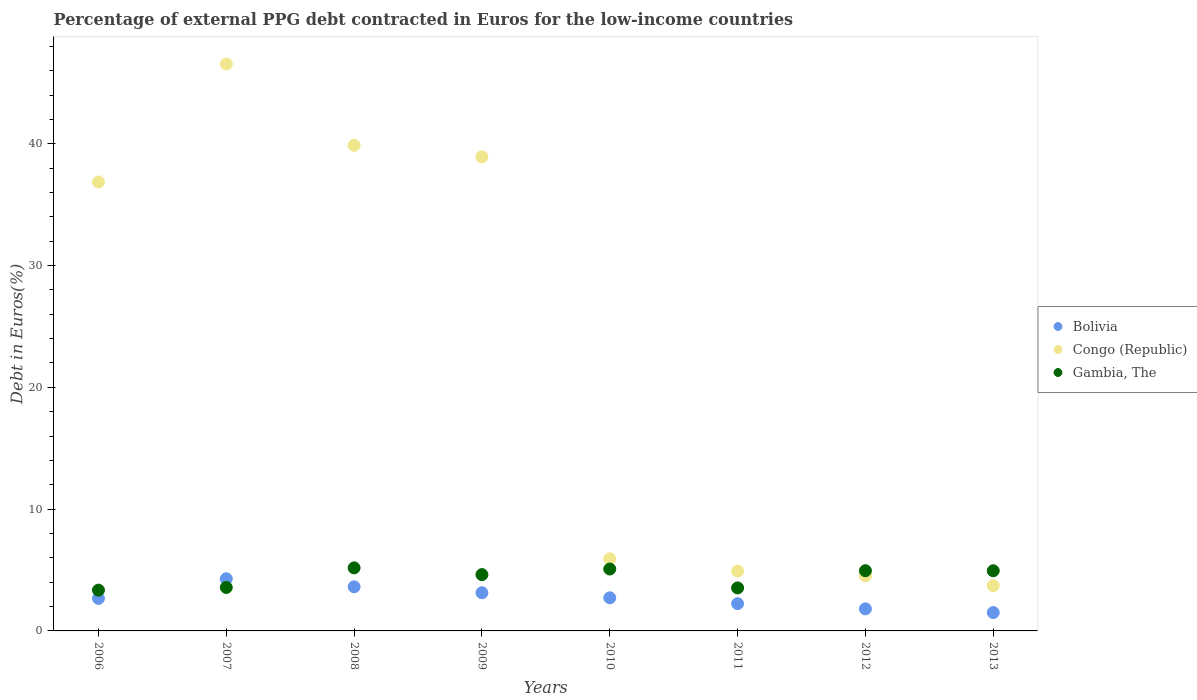What is the percentage of external PPG debt contracted in Euros in Congo (Republic) in 2009?
Your answer should be very brief. 38.93. Across all years, what is the maximum percentage of external PPG debt contracted in Euros in Bolivia?
Give a very brief answer. 4.28. Across all years, what is the minimum percentage of external PPG debt contracted in Euros in Gambia, The?
Make the answer very short. 3.35. In which year was the percentage of external PPG debt contracted in Euros in Gambia, The minimum?
Offer a very short reply. 2006. What is the total percentage of external PPG debt contracted in Euros in Congo (Republic) in the graph?
Provide a succinct answer. 181.3. What is the difference between the percentage of external PPG debt contracted in Euros in Bolivia in 2006 and that in 2009?
Provide a short and direct response. -0.46. What is the difference between the percentage of external PPG debt contracted in Euros in Congo (Republic) in 2011 and the percentage of external PPG debt contracted in Euros in Gambia, The in 2012?
Your answer should be very brief. -0.03. What is the average percentage of external PPG debt contracted in Euros in Bolivia per year?
Your response must be concise. 2.75. In the year 2007, what is the difference between the percentage of external PPG debt contracted in Euros in Congo (Republic) and percentage of external PPG debt contracted in Euros in Bolivia?
Your response must be concise. 42.27. What is the ratio of the percentage of external PPG debt contracted in Euros in Congo (Republic) in 2006 to that in 2010?
Offer a terse response. 6.22. Is the percentage of external PPG debt contracted in Euros in Bolivia in 2010 less than that in 2013?
Offer a very short reply. No. What is the difference between the highest and the second highest percentage of external PPG debt contracted in Euros in Congo (Republic)?
Provide a succinct answer. 6.67. What is the difference between the highest and the lowest percentage of external PPG debt contracted in Euros in Bolivia?
Provide a short and direct response. 2.77. In how many years, is the percentage of external PPG debt contracted in Euros in Gambia, The greater than the average percentage of external PPG debt contracted in Euros in Gambia, The taken over all years?
Offer a very short reply. 5. Is the sum of the percentage of external PPG debt contracted in Euros in Gambia, The in 2007 and 2008 greater than the maximum percentage of external PPG debt contracted in Euros in Congo (Republic) across all years?
Offer a terse response. No. Is it the case that in every year, the sum of the percentage of external PPG debt contracted in Euros in Congo (Republic) and percentage of external PPG debt contracted in Euros in Bolivia  is greater than the percentage of external PPG debt contracted in Euros in Gambia, The?
Provide a succinct answer. Yes. Is the percentage of external PPG debt contracted in Euros in Gambia, The strictly greater than the percentage of external PPG debt contracted in Euros in Bolivia over the years?
Ensure brevity in your answer.  No. Is the percentage of external PPG debt contracted in Euros in Gambia, The strictly less than the percentage of external PPG debt contracted in Euros in Bolivia over the years?
Offer a very short reply. No. How many dotlines are there?
Provide a succinct answer. 3. What is the difference between two consecutive major ticks on the Y-axis?
Keep it short and to the point. 10. Does the graph contain any zero values?
Provide a short and direct response. No. Does the graph contain grids?
Make the answer very short. No. Where does the legend appear in the graph?
Ensure brevity in your answer.  Center right. How are the legend labels stacked?
Offer a very short reply. Vertical. What is the title of the graph?
Provide a short and direct response. Percentage of external PPG debt contracted in Euros for the low-income countries. Does "El Salvador" appear as one of the legend labels in the graph?
Your answer should be compact. No. What is the label or title of the Y-axis?
Offer a terse response. Debt in Euros(%). What is the Debt in Euros(%) of Bolivia in 2006?
Keep it short and to the point. 2.67. What is the Debt in Euros(%) in Congo (Republic) in 2006?
Ensure brevity in your answer.  36.87. What is the Debt in Euros(%) in Gambia, The in 2006?
Offer a very short reply. 3.35. What is the Debt in Euros(%) of Bolivia in 2007?
Your answer should be very brief. 4.28. What is the Debt in Euros(%) in Congo (Republic) in 2007?
Provide a short and direct response. 46.55. What is the Debt in Euros(%) in Gambia, The in 2007?
Provide a short and direct response. 3.57. What is the Debt in Euros(%) of Bolivia in 2008?
Offer a terse response. 3.62. What is the Debt in Euros(%) of Congo (Republic) in 2008?
Give a very brief answer. 39.88. What is the Debt in Euros(%) of Gambia, The in 2008?
Your answer should be compact. 5.18. What is the Debt in Euros(%) of Bolivia in 2009?
Keep it short and to the point. 3.13. What is the Debt in Euros(%) of Congo (Republic) in 2009?
Your answer should be very brief. 38.93. What is the Debt in Euros(%) of Gambia, The in 2009?
Provide a short and direct response. 4.62. What is the Debt in Euros(%) of Bolivia in 2010?
Your response must be concise. 2.72. What is the Debt in Euros(%) in Congo (Republic) in 2010?
Provide a short and direct response. 5.93. What is the Debt in Euros(%) in Gambia, The in 2010?
Make the answer very short. 5.08. What is the Debt in Euros(%) of Bolivia in 2011?
Offer a terse response. 2.24. What is the Debt in Euros(%) of Congo (Republic) in 2011?
Ensure brevity in your answer.  4.91. What is the Debt in Euros(%) of Gambia, The in 2011?
Offer a terse response. 3.53. What is the Debt in Euros(%) in Bolivia in 2012?
Your answer should be very brief. 1.81. What is the Debt in Euros(%) in Congo (Republic) in 2012?
Provide a succinct answer. 4.52. What is the Debt in Euros(%) of Gambia, The in 2012?
Your response must be concise. 4.94. What is the Debt in Euros(%) of Bolivia in 2013?
Make the answer very short. 1.51. What is the Debt in Euros(%) in Congo (Republic) in 2013?
Offer a very short reply. 3.72. What is the Debt in Euros(%) in Gambia, The in 2013?
Provide a succinct answer. 4.94. Across all years, what is the maximum Debt in Euros(%) in Bolivia?
Your response must be concise. 4.28. Across all years, what is the maximum Debt in Euros(%) in Congo (Republic)?
Provide a short and direct response. 46.55. Across all years, what is the maximum Debt in Euros(%) in Gambia, The?
Provide a short and direct response. 5.18. Across all years, what is the minimum Debt in Euros(%) of Bolivia?
Provide a succinct answer. 1.51. Across all years, what is the minimum Debt in Euros(%) in Congo (Republic)?
Make the answer very short. 3.72. Across all years, what is the minimum Debt in Euros(%) in Gambia, The?
Your answer should be compact. 3.35. What is the total Debt in Euros(%) of Bolivia in the graph?
Your answer should be very brief. 21.98. What is the total Debt in Euros(%) in Congo (Republic) in the graph?
Provide a succinct answer. 181.3. What is the total Debt in Euros(%) of Gambia, The in the graph?
Your response must be concise. 35.22. What is the difference between the Debt in Euros(%) in Bolivia in 2006 and that in 2007?
Your answer should be very brief. -1.61. What is the difference between the Debt in Euros(%) in Congo (Republic) in 2006 and that in 2007?
Offer a terse response. -9.69. What is the difference between the Debt in Euros(%) in Gambia, The in 2006 and that in 2007?
Provide a short and direct response. -0.22. What is the difference between the Debt in Euros(%) in Bolivia in 2006 and that in 2008?
Offer a terse response. -0.95. What is the difference between the Debt in Euros(%) of Congo (Republic) in 2006 and that in 2008?
Offer a very short reply. -3.01. What is the difference between the Debt in Euros(%) in Gambia, The in 2006 and that in 2008?
Your response must be concise. -1.83. What is the difference between the Debt in Euros(%) in Bolivia in 2006 and that in 2009?
Your answer should be very brief. -0.46. What is the difference between the Debt in Euros(%) in Congo (Republic) in 2006 and that in 2009?
Make the answer very short. -2.06. What is the difference between the Debt in Euros(%) in Gambia, The in 2006 and that in 2009?
Provide a short and direct response. -1.27. What is the difference between the Debt in Euros(%) of Bolivia in 2006 and that in 2010?
Make the answer very short. -0.05. What is the difference between the Debt in Euros(%) in Congo (Republic) in 2006 and that in 2010?
Give a very brief answer. 30.94. What is the difference between the Debt in Euros(%) in Gambia, The in 2006 and that in 2010?
Offer a terse response. -1.73. What is the difference between the Debt in Euros(%) of Bolivia in 2006 and that in 2011?
Ensure brevity in your answer.  0.43. What is the difference between the Debt in Euros(%) of Congo (Republic) in 2006 and that in 2011?
Ensure brevity in your answer.  31.95. What is the difference between the Debt in Euros(%) in Gambia, The in 2006 and that in 2011?
Your answer should be compact. -0.18. What is the difference between the Debt in Euros(%) in Bolivia in 2006 and that in 2012?
Give a very brief answer. 0.86. What is the difference between the Debt in Euros(%) of Congo (Republic) in 2006 and that in 2012?
Your answer should be very brief. 32.35. What is the difference between the Debt in Euros(%) in Gambia, The in 2006 and that in 2012?
Offer a very short reply. -1.6. What is the difference between the Debt in Euros(%) in Bolivia in 2006 and that in 2013?
Give a very brief answer. 1.16. What is the difference between the Debt in Euros(%) in Congo (Republic) in 2006 and that in 2013?
Your answer should be compact. 33.15. What is the difference between the Debt in Euros(%) of Gambia, The in 2006 and that in 2013?
Your answer should be compact. -1.59. What is the difference between the Debt in Euros(%) in Bolivia in 2007 and that in 2008?
Make the answer very short. 0.66. What is the difference between the Debt in Euros(%) in Congo (Republic) in 2007 and that in 2008?
Give a very brief answer. 6.67. What is the difference between the Debt in Euros(%) in Gambia, The in 2007 and that in 2008?
Your response must be concise. -1.61. What is the difference between the Debt in Euros(%) of Bolivia in 2007 and that in 2009?
Offer a very short reply. 1.15. What is the difference between the Debt in Euros(%) of Congo (Republic) in 2007 and that in 2009?
Your answer should be compact. 7.62. What is the difference between the Debt in Euros(%) in Gambia, The in 2007 and that in 2009?
Keep it short and to the point. -1.05. What is the difference between the Debt in Euros(%) in Bolivia in 2007 and that in 2010?
Your answer should be compact. 1.56. What is the difference between the Debt in Euros(%) of Congo (Republic) in 2007 and that in 2010?
Your answer should be compact. 40.62. What is the difference between the Debt in Euros(%) in Gambia, The in 2007 and that in 2010?
Provide a succinct answer. -1.51. What is the difference between the Debt in Euros(%) of Bolivia in 2007 and that in 2011?
Give a very brief answer. 2.04. What is the difference between the Debt in Euros(%) of Congo (Republic) in 2007 and that in 2011?
Provide a short and direct response. 41.64. What is the difference between the Debt in Euros(%) of Gambia, The in 2007 and that in 2011?
Keep it short and to the point. 0.04. What is the difference between the Debt in Euros(%) of Bolivia in 2007 and that in 2012?
Keep it short and to the point. 2.47. What is the difference between the Debt in Euros(%) in Congo (Republic) in 2007 and that in 2012?
Give a very brief answer. 42.04. What is the difference between the Debt in Euros(%) of Gambia, The in 2007 and that in 2012?
Your answer should be very brief. -1.38. What is the difference between the Debt in Euros(%) in Bolivia in 2007 and that in 2013?
Offer a very short reply. 2.77. What is the difference between the Debt in Euros(%) of Congo (Republic) in 2007 and that in 2013?
Make the answer very short. 42.83. What is the difference between the Debt in Euros(%) of Gambia, The in 2007 and that in 2013?
Your answer should be compact. -1.37. What is the difference between the Debt in Euros(%) in Bolivia in 2008 and that in 2009?
Your answer should be very brief. 0.49. What is the difference between the Debt in Euros(%) of Congo (Republic) in 2008 and that in 2009?
Keep it short and to the point. 0.95. What is the difference between the Debt in Euros(%) of Gambia, The in 2008 and that in 2009?
Your answer should be compact. 0.55. What is the difference between the Debt in Euros(%) of Bolivia in 2008 and that in 2010?
Your answer should be very brief. 0.9. What is the difference between the Debt in Euros(%) of Congo (Republic) in 2008 and that in 2010?
Make the answer very short. 33.95. What is the difference between the Debt in Euros(%) of Gambia, The in 2008 and that in 2010?
Provide a succinct answer. 0.09. What is the difference between the Debt in Euros(%) of Bolivia in 2008 and that in 2011?
Provide a succinct answer. 1.38. What is the difference between the Debt in Euros(%) of Congo (Republic) in 2008 and that in 2011?
Ensure brevity in your answer.  34.97. What is the difference between the Debt in Euros(%) of Gambia, The in 2008 and that in 2011?
Keep it short and to the point. 1.64. What is the difference between the Debt in Euros(%) in Bolivia in 2008 and that in 2012?
Offer a terse response. 1.81. What is the difference between the Debt in Euros(%) in Congo (Republic) in 2008 and that in 2012?
Your answer should be very brief. 35.36. What is the difference between the Debt in Euros(%) in Gambia, The in 2008 and that in 2012?
Give a very brief answer. 0.23. What is the difference between the Debt in Euros(%) of Bolivia in 2008 and that in 2013?
Keep it short and to the point. 2.11. What is the difference between the Debt in Euros(%) of Congo (Republic) in 2008 and that in 2013?
Offer a terse response. 36.16. What is the difference between the Debt in Euros(%) of Gambia, The in 2008 and that in 2013?
Make the answer very short. 0.24. What is the difference between the Debt in Euros(%) of Bolivia in 2009 and that in 2010?
Offer a very short reply. 0.41. What is the difference between the Debt in Euros(%) of Congo (Republic) in 2009 and that in 2010?
Provide a succinct answer. 33. What is the difference between the Debt in Euros(%) in Gambia, The in 2009 and that in 2010?
Give a very brief answer. -0.46. What is the difference between the Debt in Euros(%) in Bolivia in 2009 and that in 2011?
Ensure brevity in your answer.  0.9. What is the difference between the Debt in Euros(%) of Congo (Republic) in 2009 and that in 2011?
Provide a succinct answer. 34.01. What is the difference between the Debt in Euros(%) in Gambia, The in 2009 and that in 2011?
Make the answer very short. 1.09. What is the difference between the Debt in Euros(%) of Bolivia in 2009 and that in 2012?
Ensure brevity in your answer.  1.32. What is the difference between the Debt in Euros(%) of Congo (Republic) in 2009 and that in 2012?
Your response must be concise. 34.41. What is the difference between the Debt in Euros(%) in Gambia, The in 2009 and that in 2012?
Ensure brevity in your answer.  -0.32. What is the difference between the Debt in Euros(%) of Bolivia in 2009 and that in 2013?
Offer a terse response. 1.63. What is the difference between the Debt in Euros(%) in Congo (Republic) in 2009 and that in 2013?
Make the answer very short. 35.21. What is the difference between the Debt in Euros(%) in Gambia, The in 2009 and that in 2013?
Give a very brief answer. -0.32. What is the difference between the Debt in Euros(%) of Bolivia in 2010 and that in 2011?
Keep it short and to the point. 0.48. What is the difference between the Debt in Euros(%) of Congo (Republic) in 2010 and that in 2011?
Give a very brief answer. 1.01. What is the difference between the Debt in Euros(%) of Gambia, The in 2010 and that in 2011?
Offer a very short reply. 1.55. What is the difference between the Debt in Euros(%) in Bolivia in 2010 and that in 2012?
Your answer should be very brief. 0.91. What is the difference between the Debt in Euros(%) of Congo (Republic) in 2010 and that in 2012?
Offer a very short reply. 1.41. What is the difference between the Debt in Euros(%) of Gambia, The in 2010 and that in 2012?
Provide a succinct answer. 0.14. What is the difference between the Debt in Euros(%) of Bolivia in 2010 and that in 2013?
Give a very brief answer. 1.21. What is the difference between the Debt in Euros(%) in Congo (Republic) in 2010 and that in 2013?
Make the answer very short. 2.21. What is the difference between the Debt in Euros(%) in Gambia, The in 2010 and that in 2013?
Your answer should be compact. 0.14. What is the difference between the Debt in Euros(%) of Bolivia in 2011 and that in 2012?
Ensure brevity in your answer.  0.43. What is the difference between the Debt in Euros(%) of Congo (Republic) in 2011 and that in 2012?
Keep it short and to the point. 0.4. What is the difference between the Debt in Euros(%) of Gambia, The in 2011 and that in 2012?
Provide a short and direct response. -1.41. What is the difference between the Debt in Euros(%) in Bolivia in 2011 and that in 2013?
Provide a short and direct response. 0.73. What is the difference between the Debt in Euros(%) of Congo (Republic) in 2011 and that in 2013?
Ensure brevity in your answer.  1.19. What is the difference between the Debt in Euros(%) in Gambia, The in 2011 and that in 2013?
Give a very brief answer. -1.41. What is the difference between the Debt in Euros(%) of Bolivia in 2012 and that in 2013?
Provide a succinct answer. 0.3. What is the difference between the Debt in Euros(%) of Congo (Republic) in 2012 and that in 2013?
Make the answer very short. 0.8. What is the difference between the Debt in Euros(%) in Gambia, The in 2012 and that in 2013?
Make the answer very short. 0.01. What is the difference between the Debt in Euros(%) in Bolivia in 2006 and the Debt in Euros(%) in Congo (Republic) in 2007?
Your response must be concise. -43.88. What is the difference between the Debt in Euros(%) in Bolivia in 2006 and the Debt in Euros(%) in Gambia, The in 2007?
Provide a succinct answer. -0.9. What is the difference between the Debt in Euros(%) of Congo (Republic) in 2006 and the Debt in Euros(%) of Gambia, The in 2007?
Your answer should be compact. 33.3. What is the difference between the Debt in Euros(%) in Bolivia in 2006 and the Debt in Euros(%) in Congo (Republic) in 2008?
Provide a short and direct response. -37.21. What is the difference between the Debt in Euros(%) of Bolivia in 2006 and the Debt in Euros(%) of Gambia, The in 2008?
Your response must be concise. -2.51. What is the difference between the Debt in Euros(%) of Congo (Republic) in 2006 and the Debt in Euros(%) of Gambia, The in 2008?
Your answer should be very brief. 31.69. What is the difference between the Debt in Euros(%) in Bolivia in 2006 and the Debt in Euros(%) in Congo (Republic) in 2009?
Keep it short and to the point. -36.26. What is the difference between the Debt in Euros(%) of Bolivia in 2006 and the Debt in Euros(%) of Gambia, The in 2009?
Your answer should be very brief. -1.95. What is the difference between the Debt in Euros(%) of Congo (Republic) in 2006 and the Debt in Euros(%) of Gambia, The in 2009?
Ensure brevity in your answer.  32.24. What is the difference between the Debt in Euros(%) in Bolivia in 2006 and the Debt in Euros(%) in Congo (Republic) in 2010?
Provide a succinct answer. -3.26. What is the difference between the Debt in Euros(%) of Bolivia in 2006 and the Debt in Euros(%) of Gambia, The in 2010?
Offer a very short reply. -2.41. What is the difference between the Debt in Euros(%) of Congo (Republic) in 2006 and the Debt in Euros(%) of Gambia, The in 2010?
Ensure brevity in your answer.  31.78. What is the difference between the Debt in Euros(%) of Bolivia in 2006 and the Debt in Euros(%) of Congo (Republic) in 2011?
Offer a terse response. -2.24. What is the difference between the Debt in Euros(%) of Bolivia in 2006 and the Debt in Euros(%) of Gambia, The in 2011?
Offer a very short reply. -0.86. What is the difference between the Debt in Euros(%) of Congo (Republic) in 2006 and the Debt in Euros(%) of Gambia, The in 2011?
Offer a terse response. 33.33. What is the difference between the Debt in Euros(%) in Bolivia in 2006 and the Debt in Euros(%) in Congo (Republic) in 2012?
Your response must be concise. -1.85. What is the difference between the Debt in Euros(%) of Bolivia in 2006 and the Debt in Euros(%) of Gambia, The in 2012?
Your answer should be very brief. -2.27. What is the difference between the Debt in Euros(%) of Congo (Republic) in 2006 and the Debt in Euros(%) of Gambia, The in 2012?
Offer a terse response. 31.92. What is the difference between the Debt in Euros(%) in Bolivia in 2006 and the Debt in Euros(%) in Congo (Republic) in 2013?
Make the answer very short. -1.05. What is the difference between the Debt in Euros(%) of Bolivia in 2006 and the Debt in Euros(%) of Gambia, The in 2013?
Make the answer very short. -2.27. What is the difference between the Debt in Euros(%) in Congo (Republic) in 2006 and the Debt in Euros(%) in Gambia, The in 2013?
Keep it short and to the point. 31.93. What is the difference between the Debt in Euros(%) of Bolivia in 2007 and the Debt in Euros(%) of Congo (Republic) in 2008?
Keep it short and to the point. -35.6. What is the difference between the Debt in Euros(%) in Bolivia in 2007 and the Debt in Euros(%) in Gambia, The in 2008?
Offer a very short reply. -0.9. What is the difference between the Debt in Euros(%) of Congo (Republic) in 2007 and the Debt in Euros(%) of Gambia, The in 2008?
Give a very brief answer. 41.38. What is the difference between the Debt in Euros(%) in Bolivia in 2007 and the Debt in Euros(%) in Congo (Republic) in 2009?
Provide a succinct answer. -34.65. What is the difference between the Debt in Euros(%) in Bolivia in 2007 and the Debt in Euros(%) in Gambia, The in 2009?
Offer a very short reply. -0.34. What is the difference between the Debt in Euros(%) of Congo (Republic) in 2007 and the Debt in Euros(%) of Gambia, The in 2009?
Give a very brief answer. 41.93. What is the difference between the Debt in Euros(%) in Bolivia in 2007 and the Debt in Euros(%) in Congo (Republic) in 2010?
Your answer should be very brief. -1.65. What is the difference between the Debt in Euros(%) of Bolivia in 2007 and the Debt in Euros(%) of Gambia, The in 2010?
Offer a terse response. -0.8. What is the difference between the Debt in Euros(%) in Congo (Republic) in 2007 and the Debt in Euros(%) in Gambia, The in 2010?
Ensure brevity in your answer.  41.47. What is the difference between the Debt in Euros(%) in Bolivia in 2007 and the Debt in Euros(%) in Congo (Republic) in 2011?
Offer a terse response. -0.63. What is the difference between the Debt in Euros(%) of Bolivia in 2007 and the Debt in Euros(%) of Gambia, The in 2011?
Provide a succinct answer. 0.75. What is the difference between the Debt in Euros(%) in Congo (Republic) in 2007 and the Debt in Euros(%) in Gambia, The in 2011?
Ensure brevity in your answer.  43.02. What is the difference between the Debt in Euros(%) of Bolivia in 2007 and the Debt in Euros(%) of Congo (Republic) in 2012?
Provide a succinct answer. -0.24. What is the difference between the Debt in Euros(%) in Bolivia in 2007 and the Debt in Euros(%) in Gambia, The in 2012?
Make the answer very short. -0.66. What is the difference between the Debt in Euros(%) of Congo (Republic) in 2007 and the Debt in Euros(%) of Gambia, The in 2012?
Provide a short and direct response. 41.61. What is the difference between the Debt in Euros(%) in Bolivia in 2007 and the Debt in Euros(%) in Congo (Republic) in 2013?
Make the answer very short. 0.56. What is the difference between the Debt in Euros(%) of Bolivia in 2007 and the Debt in Euros(%) of Gambia, The in 2013?
Your answer should be very brief. -0.66. What is the difference between the Debt in Euros(%) of Congo (Republic) in 2007 and the Debt in Euros(%) of Gambia, The in 2013?
Offer a very short reply. 41.61. What is the difference between the Debt in Euros(%) of Bolivia in 2008 and the Debt in Euros(%) of Congo (Republic) in 2009?
Make the answer very short. -35.3. What is the difference between the Debt in Euros(%) of Bolivia in 2008 and the Debt in Euros(%) of Gambia, The in 2009?
Your answer should be compact. -1. What is the difference between the Debt in Euros(%) of Congo (Republic) in 2008 and the Debt in Euros(%) of Gambia, The in 2009?
Your answer should be compact. 35.26. What is the difference between the Debt in Euros(%) in Bolivia in 2008 and the Debt in Euros(%) in Congo (Republic) in 2010?
Provide a short and direct response. -2.31. What is the difference between the Debt in Euros(%) in Bolivia in 2008 and the Debt in Euros(%) in Gambia, The in 2010?
Make the answer very short. -1.46. What is the difference between the Debt in Euros(%) in Congo (Republic) in 2008 and the Debt in Euros(%) in Gambia, The in 2010?
Keep it short and to the point. 34.8. What is the difference between the Debt in Euros(%) of Bolivia in 2008 and the Debt in Euros(%) of Congo (Republic) in 2011?
Provide a succinct answer. -1.29. What is the difference between the Debt in Euros(%) in Bolivia in 2008 and the Debt in Euros(%) in Gambia, The in 2011?
Your response must be concise. 0.09. What is the difference between the Debt in Euros(%) of Congo (Republic) in 2008 and the Debt in Euros(%) of Gambia, The in 2011?
Make the answer very short. 36.35. What is the difference between the Debt in Euros(%) in Bolivia in 2008 and the Debt in Euros(%) in Congo (Republic) in 2012?
Your answer should be very brief. -0.89. What is the difference between the Debt in Euros(%) in Bolivia in 2008 and the Debt in Euros(%) in Gambia, The in 2012?
Make the answer very short. -1.32. What is the difference between the Debt in Euros(%) in Congo (Republic) in 2008 and the Debt in Euros(%) in Gambia, The in 2012?
Keep it short and to the point. 34.93. What is the difference between the Debt in Euros(%) of Bolivia in 2008 and the Debt in Euros(%) of Congo (Republic) in 2013?
Provide a succinct answer. -0.1. What is the difference between the Debt in Euros(%) of Bolivia in 2008 and the Debt in Euros(%) of Gambia, The in 2013?
Keep it short and to the point. -1.32. What is the difference between the Debt in Euros(%) in Congo (Republic) in 2008 and the Debt in Euros(%) in Gambia, The in 2013?
Offer a very short reply. 34.94. What is the difference between the Debt in Euros(%) in Bolivia in 2009 and the Debt in Euros(%) in Congo (Republic) in 2010?
Your answer should be very brief. -2.79. What is the difference between the Debt in Euros(%) in Bolivia in 2009 and the Debt in Euros(%) in Gambia, The in 2010?
Make the answer very short. -1.95. What is the difference between the Debt in Euros(%) in Congo (Republic) in 2009 and the Debt in Euros(%) in Gambia, The in 2010?
Keep it short and to the point. 33.84. What is the difference between the Debt in Euros(%) in Bolivia in 2009 and the Debt in Euros(%) in Congo (Republic) in 2011?
Your answer should be very brief. -1.78. What is the difference between the Debt in Euros(%) in Bolivia in 2009 and the Debt in Euros(%) in Gambia, The in 2011?
Your answer should be compact. -0.4. What is the difference between the Debt in Euros(%) in Congo (Republic) in 2009 and the Debt in Euros(%) in Gambia, The in 2011?
Ensure brevity in your answer.  35.39. What is the difference between the Debt in Euros(%) of Bolivia in 2009 and the Debt in Euros(%) of Congo (Republic) in 2012?
Your answer should be compact. -1.38. What is the difference between the Debt in Euros(%) of Bolivia in 2009 and the Debt in Euros(%) of Gambia, The in 2012?
Your answer should be compact. -1.81. What is the difference between the Debt in Euros(%) of Congo (Republic) in 2009 and the Debt in Euros(%) of Gambia, The in 2012?
Provide a short and direct response. 33.98. What is the difference between the Debt in Euros(%) of Bolivia in 2009 and the Debt in Euros(%) of Congo (Republic) in 2013?
Offer a terse response. -0.59. What is the difference between the Debt in Euros(%) of Bolivia in 2009 and the Debt in Euros(%) of Gambia, The in 2013?
Your response must be concise. -1.81. What is the difference between the Debt in Euros(%) in Congo (Republic) in 2009 and the Debt in Euros(%) in Gambia, The in 2013?
Your answer should be compact. 33.99. What is the difference between the Debt in Euros(%) in Bolivia in 2010 and the Debt in Euros(%) in Congo (Republic) in 2011?
Provide a succinct answer. -2.19. What is the difference between the Debt in Euros(%) in Bolivia in 2010 and the Debt in Euros(%) in Gambia, The in 2011?
Offer a very short reply. -0.81. What is the difference between the Debt in Euros(%) in Congo (Republic) in 2010 and the Debt in Euros(%) in Gambia, The in 2011?
Offer a very short reply. 2.4. What is the difference between the Debt in Euros(%) of Bolivia in 2010 and the Debt in Euros(%) of Congo (Republic) in 2012?
Provide a short and direct response. -1.8. What is the difference between the Debt in Euros(%) of Bolivia in 2010 and the Debt in Euros(%) of Gambia, The in 2012?
Make the answer very short. -2.23. What is the difference between the Debt in Euros(%) in Congo (Republic) in 2010 and the Debt in Euros(%) in Gambia, The in 2012?
Your response must be concise. 0.98. What is the difference between the Debt in Euros(%) in Bolivia in 2010 and the Debt in Euros(%) in Congo (Republic) in 2013?
Provide a short and direct response. -1. What is the difference between the Debt in Euros(%) in Bolivia in 2010 and the Debt in Euros(%) in Gambia, The in 2013?
Your answer should be very brief. -2.22. What is the difference between the Debt in Euros(%) in Congo (Republic) in 2010 and the Debt in Euros(%) in Gambia, The in 2013?
Make the answer very short. 0.99. What is the difference between the Debt in Euros(%) of Bolivia in 2011 and the Debt in Euros(%) of Congo (Republic) in 2012?
Provide a short and direct response. -2.28. What is the difference between the Debt in Euros(%) in Bolivia in 2011 and the Debt in Euros(%) in Gambia, The in 2012?
Your response must be concise. -2.71. What is the difference between the Debt in Euros(%) in Congo (Republic) in 2011 and the Debt in Euros(%) in Gambia, The in 2012?
Offer a terse response. -0.03. What is the difference between the Debt in Euros(%) of Bolivia in 2011 and the Debt in Euros(%) of Congo (Republic) in 2013?
Provide a succinct answer. -1.48. What is the difference between the Debt in Euros(%) in Bolivia in 2011 and the Debt in Euros(%) in Gambia, The in 2013?
Your answer should be compact. -2.7. What is the difference between the Debt in Euros(%) in Congo (Republic) in 2011 and the Debt in Euros(%) in Gambia, The in 2013?
Your answer should be very brief. -0.03. What is the difference between the Debt in Euros(%) in Bolivia in 2012 and the Debt in Euros(%) in Congo (Republic) in 2013?
Make the answer very short. -1.91. What is the difference between the Debt in Euros(%) of Bolivia in 2012 and the Debt in Euros(%) of Gambia, The in 2013?
Your answer should be very brief. -3.13. What is the difference between the Debt in Euros(%) in Congo (Republic) in 2012 and the Debt in Euros(%) in Gambia, The in 2013?
Give a very brief answer. -0.42. What is the average Debt in Euros(%) in Bolivia per year?
Offer a terse response. 2.75. What is the average Debt in Euros(%) of Congo (Republic) per year?
Offer a terse response. 22.66. What is the average Debt in Euros(%) of Gambia, The per year?
Your answer should be compact. 4.4. In the year 2006, what is the difference between the Debt in Euros(%) in Bolivia and Debt in Euros(%) in Congo (Republic)?
Your response must be concise. -34.19. In the year 2006, what is the difference between the Debt in Euros(%) of Bolivia and Debt in Euros(%) of Gambia, The?
Make the answer very short. -0.68. In the year 2006, what is the difference between the Debt in Euros(%) of Congo (Republic) and Debt in Euros(%) of Gambia, The?
Your answer should be compact. 33.52. In the year 2007, what is the difference between the Debt in Euros(%) of Bolivia and Debt in Euros(%) of Congo (Republic)?
Make the answer very short. -42.27. In the year 2007, what is the difference between the Debt in Euros(%) of Bolivia and Debt in Euros(%) of Gambia, The?
Your answer should be compact. 0.71. In the year 2007, what is the difference between the Debt in Euros(%) of Congo (Republic) and Debt in Euros(%) of Gambia, The?
Your answer should be compact. 42.98. In the year 2008, what is the difference between the Debt in Euros(%) in Bolivia and Debt in Euros(%) in Congo (Republic)?
Offer a very short reply. -36.26. In the year 2008, what is the difference between the Debt in Euros(%) in Bolivia and Debt in Euros(%) in Gambia, The?
Make the answer very short. -1.55. In the year 2008, what is the difference between the Debt in Euros(%) in Congo (Republic) and Debt in Euros(%) in Gambia, The?
Make the answer very short. 34.7. In the year 2009, what is the difference between the Debt in Euros(%) of Bolivia and Debt in Euros(%) of Congo (Republic)?
Give a very brief answer. -35.79. In the year 2009, what is the difference between the Debt in Euros(%) in Bolivia and Debt in Euros(%) in Gambia, The?
Keep it short and to the point. -1.49. In the year 2009, what is the difference between the Debt in Euros(%) in Congo (Republic) and Debt in Euros(%) in Gambia, The?
Offer a very short reply. 34.3. In the year 2010, what is the difference between the Debt in Euros(%) in Bolivia and Debt in Euros(%) in Congo (Republic)?
Make the answer very short. -3.21. In the year 2010, what is the difference between the Debt in Euros(%) of Bolivia and Debt in Euros(%) of Gambia, The?
Provide a succinct answer. -2.36. In the year 2010, what is the difference between the Debt in Euros(%) in Congo (Republic) and Debt in Euros(%) in Gambia, The?
Offer a very short reply. 0.84. In the year 2011, what is the difference between the Debt in Euros(%) of Bolivia and Debt in Euros(%) of Congo (Republic)?
Make the answer very short. -2.67. In the year 2011, what is the difference between the Debt in Euros(%) in Bolivia and Debt in Euros(%) in Gambia, The?
Give a very brief answer. -1.29. In the year 2011, what is the difference between the Debt in Euros(%) in Congo (Republic) and Debt in Euros(%) in Gambia, The?
Ensure brevity in your answer.  1.38. In the year 2012, what is the difference between the Debt in Euros(%) of Bolivia and Debt in Euros(%) of Congo (Republic)?
Ensure brevity in your answer.  -2.71. In the year 2012, what is the difference between the Debt in Euros(%) of Bolivia and Debt in Euros(%) of Gambia, The?
Provide a succinct answer. -3.13. In the year 2012, what is the difference between the Debt in Euros(%) in Congo (Republic) and Debt in Euros(%) in Gambia, The?
Give a very brief answer. -0.43. In the year 2013, what is the difference between the Debt in Euros(%) of Bolivia and Debt in Euros(%) of Congo (Republic)?
Ensure brevity in your answer.  -2.21. In the year 2013, what is the difference between the Debt in Euros(%) of Bolivia and Debt in Euros(%) of Gambia, The?
Your answer should be compact. -3.43. In the year 2013, what is the difference between the Debt in Euros(%) of Congo (Republic) and Debt in Euros(%) of Gambia, The?
Provide a short and direct response. -1.22. What is the ratio of the Debt in Euros(%) in Bolivia in 2006 to that in 2007?
Provide a succinct answer. 0.62. What is the ratio of the Debt in Euros(%) in Congo (Republic) in 2006 to that in 2007?
Ensure brevity in your answer.  0.79. What is the ratio of the Debt in Euros(%) of Gambia, The in 2006 to that in 2007?
Provide a short and direct response. 0.94. What is the ratio of the Debt in Euros(%) in Bolivia in 2006 to that in 2008?
Your answer should be compact. 0.74. What is the ratio of the Debt in Euros(%) in Congo (Republic) in 2006 to that in 2008?
Provide a succinct answer. 0.92. What is the ratio of the Debt in Euros(%) in Gambia, The in 2006 to that in 2008?
Provide a short and direct response. 0.65. What is the ratio of the Debt in Euros(%) of Bolivia in 2006 to that in 2009?
Your response must be concise. 0.85. What is the ratio of the Debt in Euros(%) of Congo (Republic) in 2006 to that in 2009?
Your answer should be very brief. 0.95. What is the ratio of the Debt in Euros(%) of Gambia, The in 2006 to that in 2009?
Your response must be concise. 0.72. What is the ratio of the Debt in Euros(%) of Bolivia in 2006 to that in 2010?
Your response must be concise. 0.98. What is the ratio of the Debt in Euros(%) of Congo (Republic) in 2006 to that in 2010?
Offer a very short reply. 6.22. What is the ratio of the Debt in Euros(%) in Gambia, The in 2006 to that in 2010?
Your answer should be very brief. 0.66. What is the ratio of the Debt in Euros(%) of Bolivia in 2006 to that in 2011?
Your answer should be compact. 1.19. What is the ratio of the Debt in Euros(%) in Congo (Republic) in 2006 to that in 2011?
Provide a succinct answer. 7.5. What is the ratio of the Debt in Euros(%) of Gambia, The in 2006 to that in 2011?
Your answer should be very brief. 0.95. What is the ratio of the Debt in Euros(%) of Bolivia in 2006 to that in 2012?
Give a very brief answer. 1.48. What is the ratio of the Debt in Euros(%) of Congo (Republic) in 2006 to that in 2012?
Offer a terse response. 8.16. What is the ratio of the Debt in Euros(%) in Gambia, The in 2006 to that in 2012?
Make the answer very short. 0.68. What is the ratio of the Debt in Euros(%) in Bolivia in 2006 to that in 2013?
Offer a terse response. 1.77. What is the ratio of the Debt in Euros(%) in Congo (Republic) in 2006 to that in 2013?
Keep it short and to the point. 9.91. What is the ratio of the Debt in Euros(%) of Gambia, The in 2006 to that in 2013?
Offer a very short reply. 0.68. What is the ratio of the Debt in Euros(%) of Bolivia in 2007 to that in 2008?
Your response must be concise. 1.18. What is the ratio of the Debt in Euros(%) of Congo (Republic) in 2007 to that in 2008?
Provide a short and direct response. 1.17. What is the ratio of the Debt in Euros(%) of Gambia, The in 2007 to that in 2008?
Ensure brevity in your answer.  0.69. What is the ratio of the Debt in Euros(%) of Bolivia in 2007 to that in 2009?
Provide a succinct answer. 1.37. What is the ratio of the Debt in Euros(%) in Congo (Republic) in 2007 to that in 2009?
Ensure brevity in your answer.  1.2. What is the ratio of the Debt in Euros(%) in Gambia, The in 2007 to that in 2009?
Keep it short and to the point. 0.77. What is the ratio of the Debt in Euros(%) of Bolivia in 2007 to that in 2010?
Your answer should be very brief. 1.57. What is the ratio of the Debt in Euros(%) in Congo (Republic) in 2007 to that in 2010?
Ensure brevity in your answer.  7.85. What is the ratio of the Debt in Euros(%) in Gambia, The in 2007 to that in 2010?
Make the answer very short. 0.7. What is the ratio of the Debt in Euros(%) of Bolivia in 2007 to that in 2011?
Your response must be concise. 1.91. What is the ratio of the Debt in Euros(%) in Congo (Republic) in 2007 to that in 2011?
Your answer should be compact. 9.47. What is the ratio of the Debt in Euros(%) in Gambia, The in 2007 to that in 2011?
Ensure brevity in your answer.  1.01. What is the ratio of the Debt in Euros(%) of Bolivia in 2007 to that in 2012?
Provide a succinct answer. 2.36. What is the ratio of the Debt in Euros(%) in Congo (Republic) in 2007 to that in 2012?
Give a very brief answer. 10.31. What is the ratio of the Debt in Euros(%) of Gambia, The in 2007 to that in 2012?
Make the answer very short. 0.72. What is the ratio of the Debt in Euros(%) in Bolivia in 2007 to that in 2013?
Offer a terse response. 2.84. What is the ratio of the Debt in Euros(%) of Congo (Republic) in 2007 to that in 2013?
Your answer should be very brief. 12.52. What is the ratio of the Debt in Euros(%) of Gambia, The in 2007 to that in 2013?
Give a very brief answer. 0.72. What is the ratio of the Debt in Euros(%) of Bolivia in 2008 to that in 2009?
Provide a short and direct response. 1.16. What is the ratio of the Debt in Euros(%) in Congo (Republic) in 2008 to that in 2009?
Provide a succinct answer. 1.02. What is the ratio of the Debt in Euros(%) in Gambia, The in 2008 to that in 2009?
Your answer should be very brief. 1.12. What is the ratio of the Debt in Euros(%) in Bolivia in 2008 to that in 2010?
Provide a short and direct response. 1.33. What is the ratio of the Debt in Euros(%) of Congo (Republic) in 2008 to that in 2010?
Your answer should be compact. 6.73. What is the ratio of the Debt in Euros(%) of Gambia, The in 2008 to that in 2010?
Offer a terse response. 1.02. What is the ratio of the Debt in Euros(%) of Bolivia in 2008 to that in 2011?
Your response must be concise. 1.62. What is the ratio of the Debt in Euros(%) in Congo (Republic) in 2008 to that in 2011?
Your answer should be very brief. 8.12. What is the ratio of the Debt in Euros(%) of Gambia, The in 2008 to that in 2011?
Offer a terse response. 1.47. What is the ratio of the Debt in Euros(%) in Bolivia in 2008 to that in 2012?
Provide a succinct answer. 2. What is the ratio of the Debt in Euros(%) in Congo (Republic) in 2008 to that in 2012?
Provide a succinct answer. 8.83. What is the ratio of the Debt in Euros(%) of Gambia, The in 2008 to that in 2012?
Keep it short and to the point. 1.05. What is the ratio of the Debt in Euros(%) in Bolivia in 2008 to that in 2013?
Provide a succinct answer. 2.4. What is the ratio of the Debt in Euros(%) of Congo (Republic) in 2008 to that in 2013?
Keep it short and to the point. 10.72. What is the ratio of the Debt in Euros(%) of Gambia, The in 2008 to that in 2013?
Make the answer very short. 1.05. What is the ratio of the Debt in Euros(%) in Bolivia in 2009 to that in 2010?
Your answer should be compact. 1.15. What is the ratio of the Debt in Euros(%) of Congo (Republic) in 2009 to that in 2010?
Make the answer very short. 6.57. What is the ratio of the Debt in Euros(%) of Gambia, The in 2009 to that in 2010?
Provide a succinct answer. 0.91. What is the ratio of the Debt in Euros(%) in Congo (Republic) in 2009 to that in 2011?
Keep it short and to the point. 7.92. What is the ratio of the Debt in Euros(%) of Gambia, The in 2009 to that in 2011?
Offer a terse response. 1.31. What is the ratio of the Debt in Euros(%) in Bolivia in 2009 to that in 2012?
Your answer should be very brief. 1.73. What is the ratio of the Debt in Euros(%) of Congo (Republic) in 2009 to that in 2012?
Give a very brief answer. 8.62. What is the ratio of the Debt in Euros(%) of Gambia, The in 2009 to that in 2012?
Your answer should be compact. 0.93. What is the ratio of the Debt in Euros(%) in Bolivia in 2009 to that in 2013?
Your answer should be compact. 2.08. What is the ratio of the Debt in Euros(%) of Congo (Republic) in 2009 to that in 2013?
Provide a short and direct response. 10.47. What is the ratio of the Debt in Euros(%) of Gambia, The in 2009 to that in 2013?
Keep it short and to the point. 0.94. What is the ratio of the Debt in Euros(%) in Bolivia in 2010 to that in 2011?
Give a very brief answer. 1.21. What is the ratio of the Debt in Euros(%) of Congo (Republic) in 2010 to that in 2011?
Provide a short and direct response. 1.21. What is the ratio of the Debt in Euros(%) of Gambia, The in 2010 to that in 2011?
Offer a terse response. 1.44. What is the ratio of the Debt in Euros(%) in Bolivia in 2010 to that in 2012?
Offer a very short reply. 1.5. What is the ratio of the Debt in Euros(%) of Congo (Republic) in 2010 to that in 2012?
Offer a terse response. 1.31. What is the ratio of the Debt in Euros(%) of Gambia, The in 2010 to that in 2012?
Your response must be concise. 1.03. What is the ratio of the Debt in Euros(%) in Bolivia in 2010 to that in 2013?
Offer a very short reply. 1.8. What is the ratio of the Debt in Euros(%) in Congo (Republic) in 2010 to that in 2013?
Offer a terse response. 1.59. What is the ratio of the Debt in Euros(%) in Gambia, The in 2010 to that in 2013?
Ensure brevity in your answer.  1.03. What is the ratio of the Debt in Euros(%) of Bolivia in 2011 to that in 2012?
Your response must be concise. 1.24. What is the ratio of the Debt in Euros(%) in Congo (Republic) in 2011 to that in 2012?
Provide a short and direct response. 1.09. What is the ratio of the Debt in Euros(%) of Bolivia in 2011 to that in 2013?
Make the answer very short. 1.48. What is the ratio of the Debt in Euros(%) in Congo (Republic) in 2011 to that in 2013?
Offer a terse response. 1.32. What is the ratio of the Debt in Euros(%) of Gambia, The in 2011 to that in 2013?
Your response must be concise. 0.71. What is the ratio of the Debt in Euros(%) of Congo (Republic) in 2012 to that in 2013?
Provide a short and direct response. 1.21. What is the difference between the highest and the second highest Debt in Euros(%) of Bolivia?
Your answer should be compact. 0.66. What is the difference between the highest and the second highest Debt in Euros(%) of Congo (Republic)?
Provide a succinct answer. 6.67. What is the difference between the highest and the second highest Debt in Euros(%) in Gambia, The?
Your answer should be compact. 0.09. What is the difference between the highest and the lowest Debt in Euros(%) of Bolivia?
Make the answer very short. 2.77. What is the difference between the highest and the lowest Debt in Euros(%) in Congo (Republic)?
Provide a short and direct response. 42.83. What is the difference between the highest and the lowest Debt in Euros(%) in Gambia, The?
Provide a short and direct response. 1.83. 